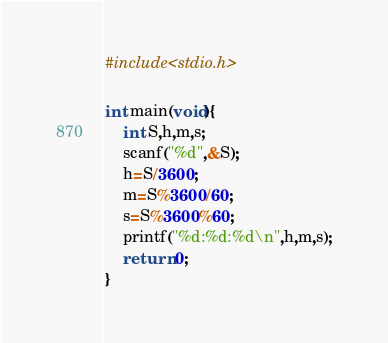<code> <loc_0><loc_0><loc_500><loc_500><_C_>#include<stdio.h>

int main(void){
    int S,h,m,s;
	scanf("%d",&S);
	h=S/3600;
	m=S%3600/60;
	s=S%3600%60;
	printf("%d:%d:%d\n",h,m,s);
    return 0;
}</code> 